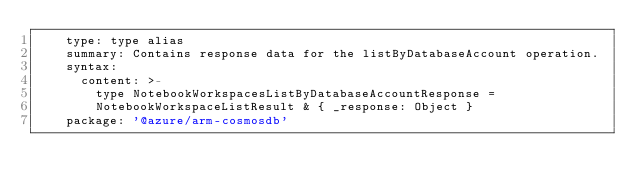<code> <loc_0><loc_0><loc_500><loc_500><_YAML_>    type: type alias
    summary: Contains response data for the listByDatabaseAccount operation.
    syntax:
      content: >-
        type NotebookWorkspacesListByDatabaseAccountResponse =
        NotebookWorkspaceListResult & { _response: Object }
    package: '@azure/arm-cosmosdb'
</code> 